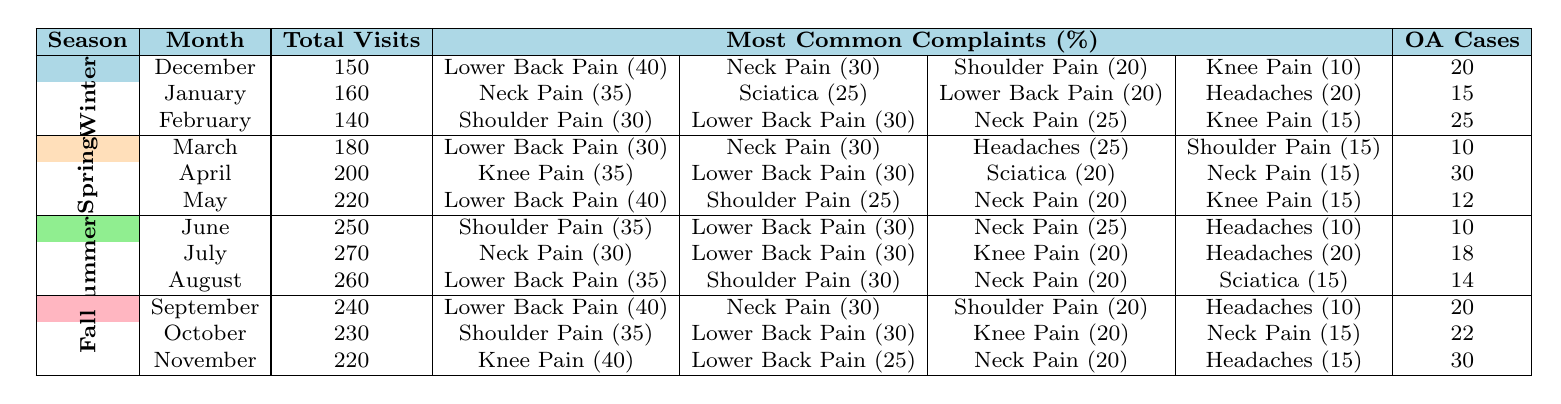What is the total number of visits in April? The table shows that the total visits for April under Spring is 200.
Answer: 200 Which complaint had the highest percentage in February? According to the table, Shoulder Pain and Lower Back Pain both have a percentage of 30%, but since Shoulder Pain is listed first, it is the complaint with the highest percentage.
Answer: Shoulder Pain How many OA cases were reported in the Winter months? The OA cases for Winter months can be summed as follows: December (20) + January (15) + February (25) = 60.
Answer: 60 What was the most common complaint in May? The table indicates that the most common complaint in May was Lower Back Pain, which had a percentage of 40.
Answer: Lower Back Pain In which month was the total visits the highest? By comparing the total visits across all months, June has the highest total visits at 250.
Answer: June What was the average number of OA cases across all seasons in November? Summing the OA cases for the Fall, which are September (20), October (22), and November (30), gives: (20 + 22 + 30) / 3 = 24.
Answer: 24 Which season had the highest total visits overall? The total visits across the seasons are calculated as Winter (150 + 160 + 140 = 450), Spring (180 + 200 + 220 = 600), Summer (250 + 270 + 260 = 780), and Fall (240 + 230 + 220 = 690). The highest total is Summer with 780 visits.
Answer: Summer Is there an increase or decrease in OA cases from December to February? The OA cases for December are 20, January are 15, and February are 25. Observing these values, there is a decrease of 5 from December to January, then an increase of 10 from January to February. Thus, the overall change is an increase of 5 cases from December to February.
Answer: Increase What is the total number of knee pain cases reported during the Spring months? The cases reported during Spring months are: March (0), April (35), and May (15). Summing these values gives: 0 + 35 + 15 = 50.
Answer: 50 During which month does the percentage of neck pain reach its peak? The month that shows the highest percentage of neck pain is January with 35%.
Answer: January Were there more total visits in Summer than in Winter? Total visits in Summer are 780 (250 + 270 + 260) and in Winter are 450 (150 + 160 + 140). Since 780 is greater than 450, there were indeed more visits in Summer than Winter.
Answer: Yes 